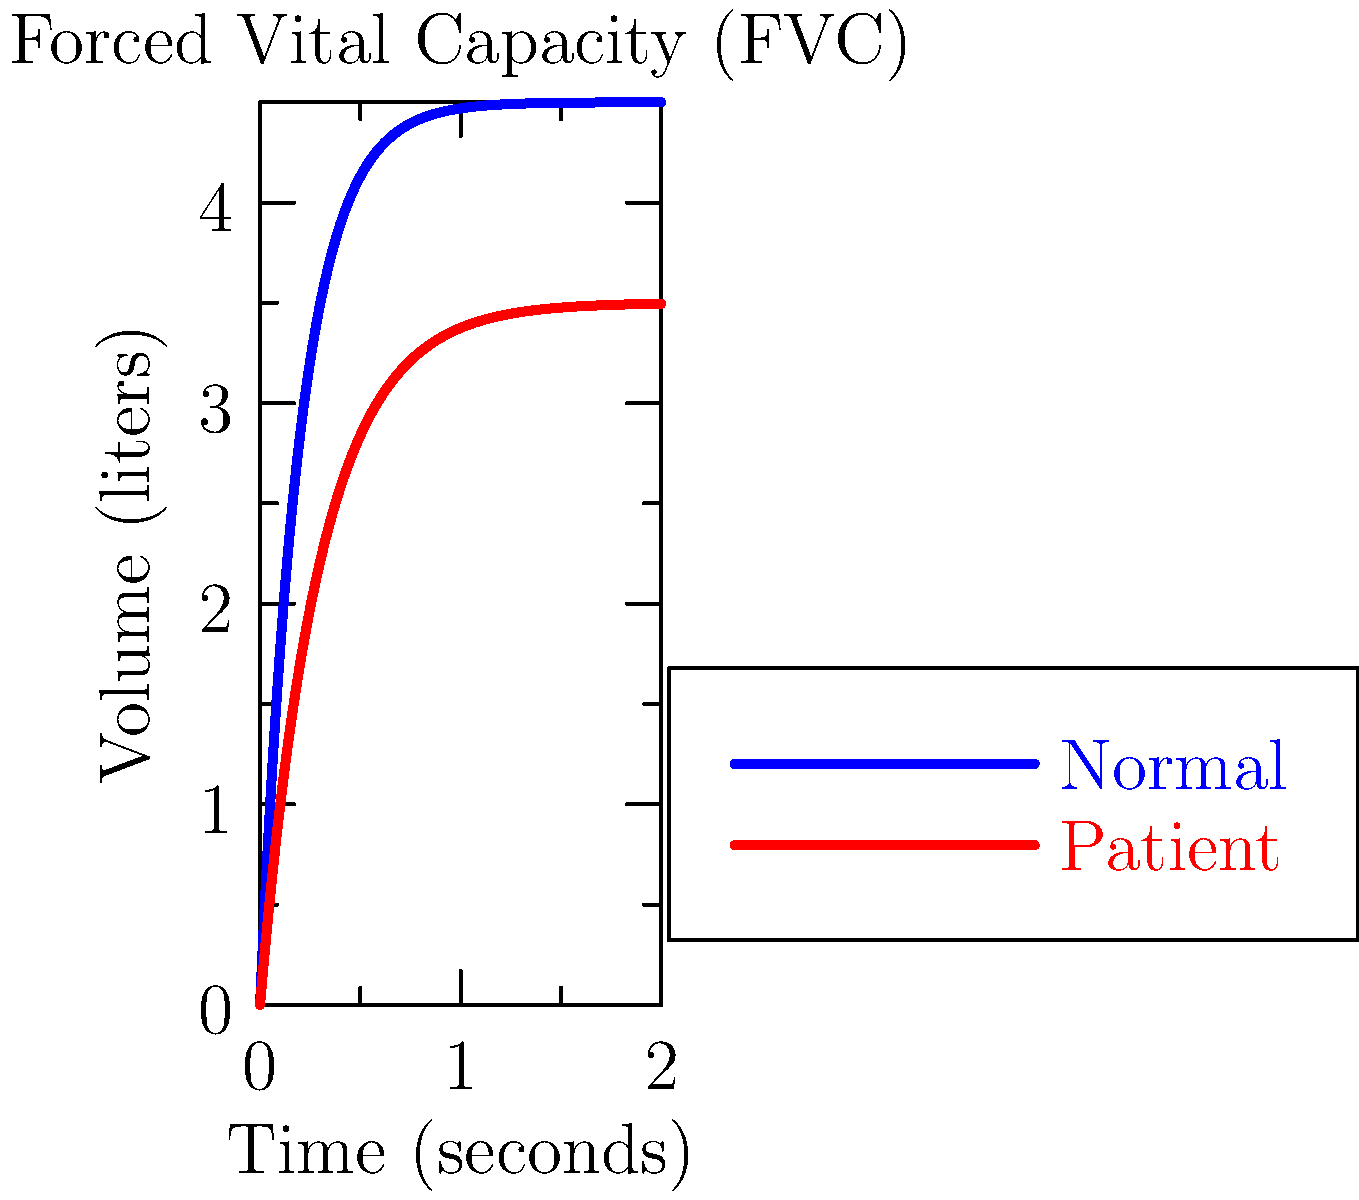Based on the spirometry graph showing lung capacity over time, what can be concluded about the patient's respiratory function compared to normal, and what potential condition might this indicate? To analyze the spirometry graph and assess the patient's respiratory function:

1. Observe the curves:
   - Blue curve represents normal lung function
   - Red curve represents the patient's lung function

2. Compare the Forced Vital Capacity (FVC):
   - Normal FVC (blue curve) reaches about 4.5 liters
   - Patient's FVC (red curve) reaches about 3.5 liters

3. Assess the rate of exhalation:
   - Normal curve shows a steeper initial slope
   - Patient's curve has a less steep slope

4. Calculate the percentage of normal FVC:
   Patient's FVC / Normal FVC = 3.5 / 4.5 ≈ 0.78 or 78%

5. Interpret the results:
   - The patient's FVC is reduced to about 78% of normal
   - The slower rate of exhalation suggests airflow limitation

6. Consider potential conditions:
   - Reduced FVC and slower exhalation are consistent with obstructive lung disease
   - Common obstructive diseases include asthma, chronic obstructive pulmonary disease (COPD), or bronchitis

Conclusion: The patient shows signs of moderate airflow limitation and reduced lung capacity, indicative of an obstructive lung disease.
Answer: Moderate airflow limitation and reduced lung capacity (78% of normal FVC), suggesting obstructive lung disease 